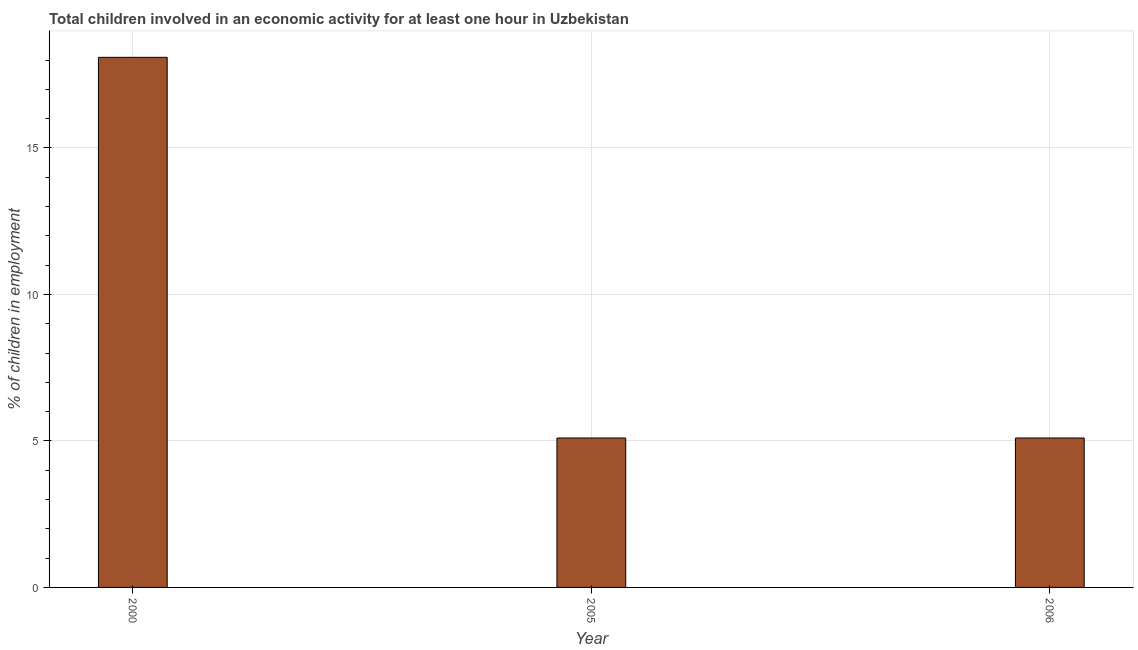Does the graph contain any zero values?
Give a very brief answer. No. Does the graph contain grids?
Offer a terse response. Yes. What is the title of the graph?
Give a very brief answer. Total children involved in an economic activity for at least one hour in Uzbekistan. What is the label or title of the X-axis?
Your response must be concise. Year. What is the label or title of the Y-axis?
Your answer should be compact. % of children in employment. Across all years, what is the maximum percentage of children in employment?
Offer a terse response. 18.09. Across all years, what is the minimum percentage of children in employment?
Offer a very short reply. 5.1. What is the sum of the percentage of children in employment?
Give a very brief answer. 28.29. What is the difference between the percentage of children in employment in 2000 and 2005?
Provide a short and direct response. 12.99. What is the average percentage of children in employment per year?
Offer a very short reply. 9.43. In how many years, is the percentage of children in employment greater than 8 %?
Provide a succinct answer. 1. Do a majority of the years between 2000 and 2005 (inclusive) have percentage of children in employment greater than 3 %?
Your answer should be very brief. Yes. What is the ratio of the percentage of children in employment in 2005 to that in 2006?
Your answer should be compact. 1. Is the difference between the percentage of children in employment in 2005 and 2006 greater than the difference between any two years?
Keep it short and to the point. No. What is the difference between the highest and the second highest percentage of children in employment?
Your answer should be very brief. 12.99. Is the sum of the percentage of children in employment in 2005 and 2006 greater than the maximum percentage of children in employment across all years?
Give a very brief answer. No. What is the difference between the highest and the lowest percentage of children in employment?
Make the answer very short. 12.99. How many bars are there?
Give a very brief answer. 3. How many years are there in the graph?
Your answer should be compact. 3. Are the values on the major ticks of Y-axis written in scientific E-notation?
Offer a very short reply. No. What is the % of children in employment of 2000?
Offer a terse response. 18.09. What is the difference between the % of children in employment in 2000 and 2005?
Your response must be concise. 12.99. What is the difference between the % of children in employment in 2000 and 2006?
Offer a terse response. 12.99. What is the difference between the % of children in employment in 2005 and 2006?
Provide a succinct answer. 0. What is the ratio of the % of children in employment in 2000 to that in 2005?
Your answer should be compact. 3.55. What is the ratio of the % of children in employment in 2000 to that in 2006?
Ensure brevity in your answer.  3.55. 